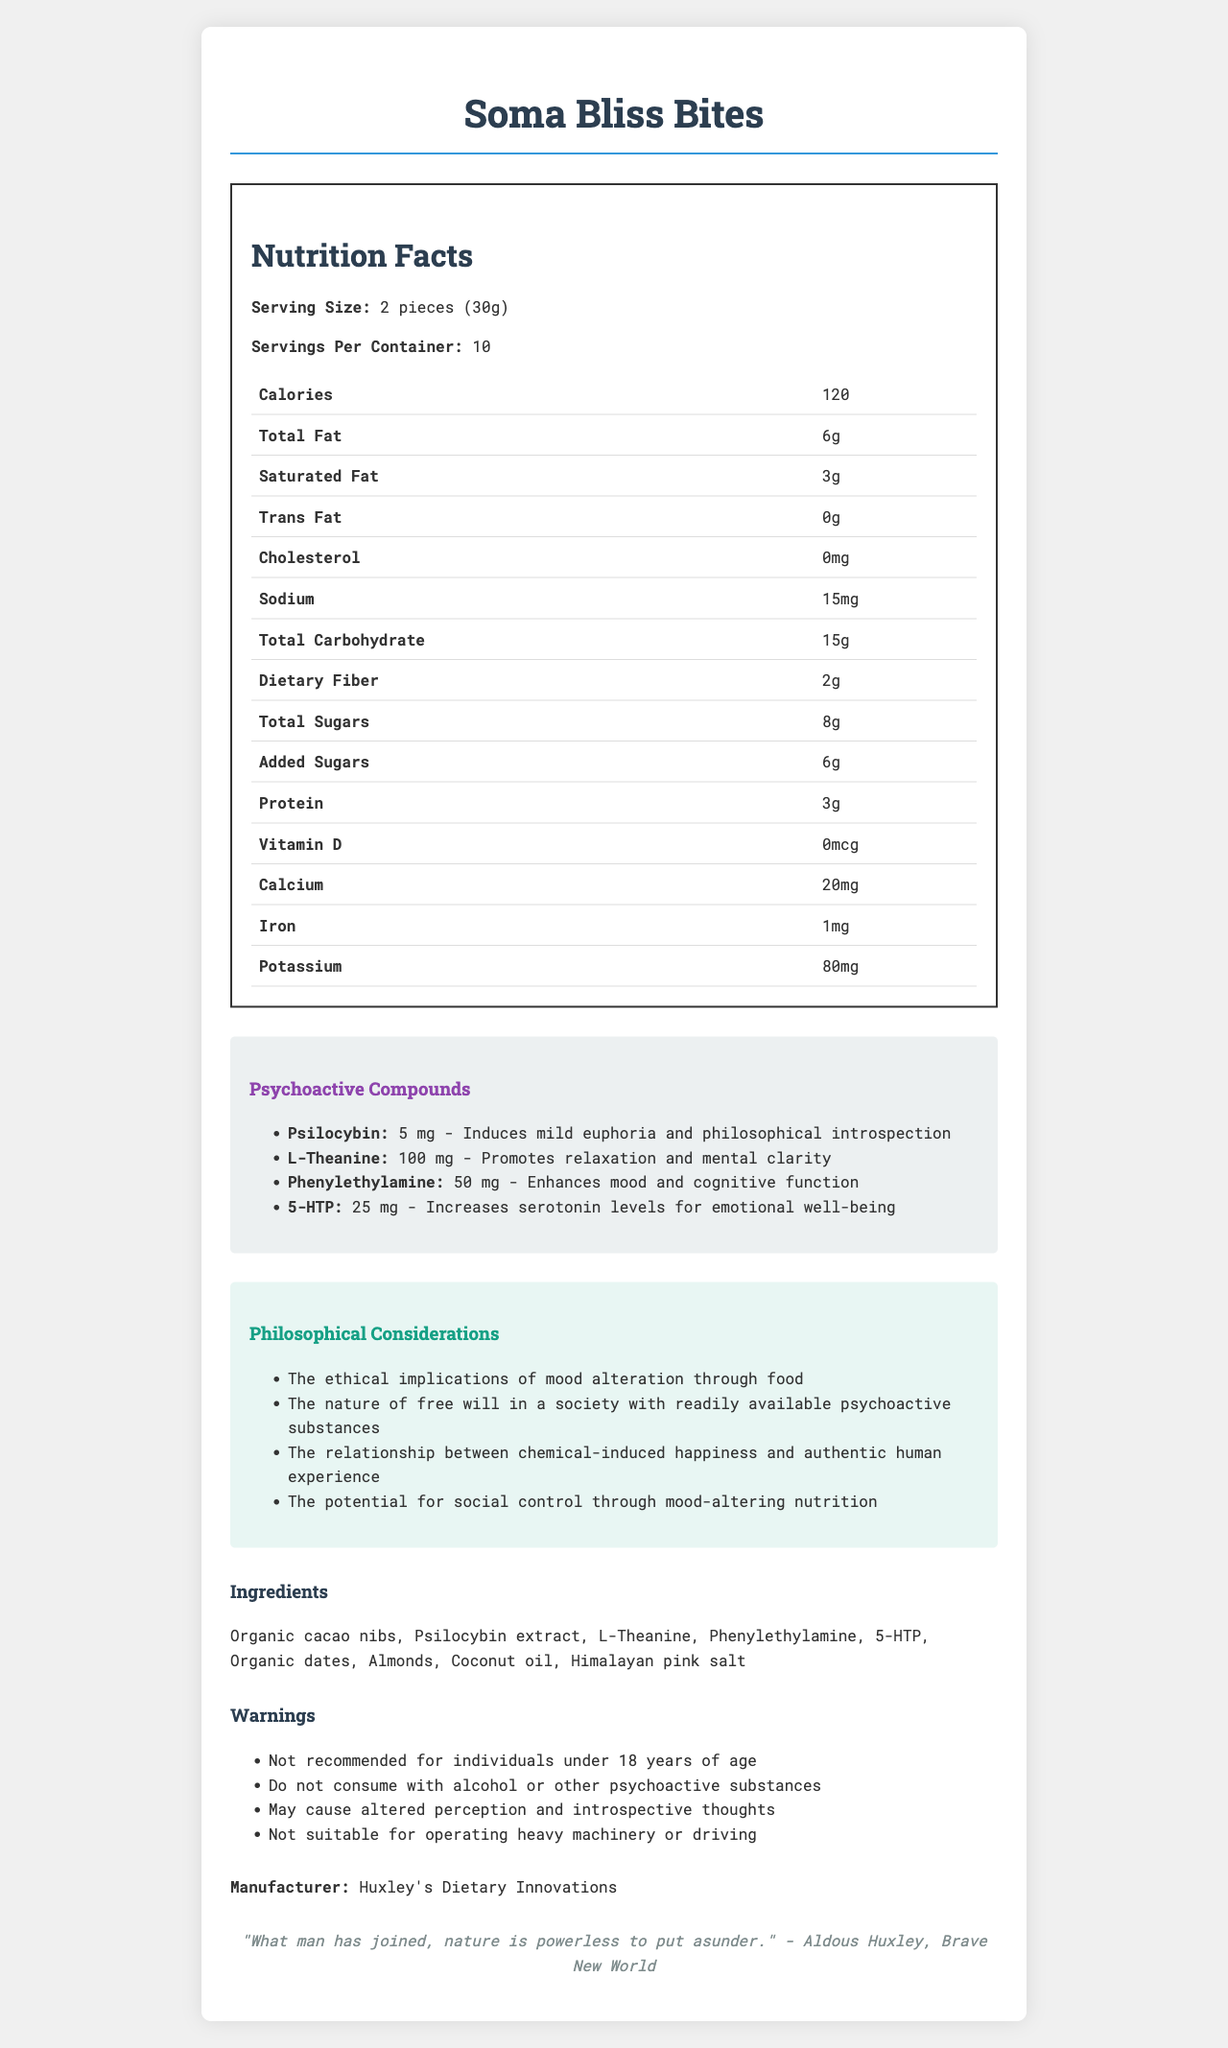What is the serving size of Soma Bliss Bites? The document specifies that the serving size is 2 pieces, which equals 30 grams.
Answer: 2 pieces (30g) How many servings are there per container? The document states that there are 10 servings per container.
Answer: 10 What is the main effect of Psilocybin in Soma Bliss Bites? The document lists the effect of Psilocybin as inducing mild euphoria and philosophical introspection.
Answer: Induces mild euphoria and philosophical introspection How much L-Theanine is included in each serving of Soma Bliss Bites? The document specifies that each serving contains 100 mg of L-Theanine.
Answer: 100 mg Which psychoactive compound in Soma Bliss Bites is meant to promote relaxation and mental clarity? L-Theanine's described effect in the document is to promote relaxation and mental clarity.
Answer: L-Theanine What are the potential risks associated with consuming Soma Bliss Bites while operating heavy machinery? The warnings section of the document indicates that consuming this product while operating heavy machinery could lead to altered perception and introspective thoughts.
Answer: May cause altered perception and introspective thoughts How many total sugars are there in one serving? The document lists the total sugars per serving as 8 grams.
Answer: 8g Which of the following ingredients is not listed in Soma Bliss Bites? (A) Organic dates (B) Almonds (C) Honey (D) Coconut oil The document lists Organic dates, Almonds, and Coconut oil as ingredients, but not Honey.
Answer: C) Honey Which psychoactive compound is used to enhance mood and cognitive function? (I) Psilocybin (II) L-Theanine (III) Phenylethylamine (IV) 5-HTP According to the document, Phenylethylamine's effect is to enhance mood and cognitive function.
Answer: III) Phenylethylamine Is Soma Bliss Bites recommended for individuals under 18 years of age? The document explicitly states that it is not recommended for individuals under 18 years of age.
Answer: No Summarize the main idea of the document. The document provides nutritional details, lists psychoactive compounds with their effects, includes philosophical considerations, and specifies warnings and manufacturer information, all relating to a snack designed to alter moods in a manner inspired by Aldous Huxley's "Brave New World".
Answer: Soma Bliss Bites is a mood-altering snack with detailed nutritional information, psychoactive compounds, and philosophical considerations. It offers both nutritional and psychological benefits but comes with warnings about its appropriate use and potential risks. The product is manufactured by Huxley's Dietary Innovations and is inspired by ideas from "Brave New World". What is the ethical stance of the manufacturer on the topic of mood alteration through food? The document lists philosophical considerations such as the ethical implications of mood alteration through food but does not provide a specific stance from the manufacturer.
Answer: Not enough information 